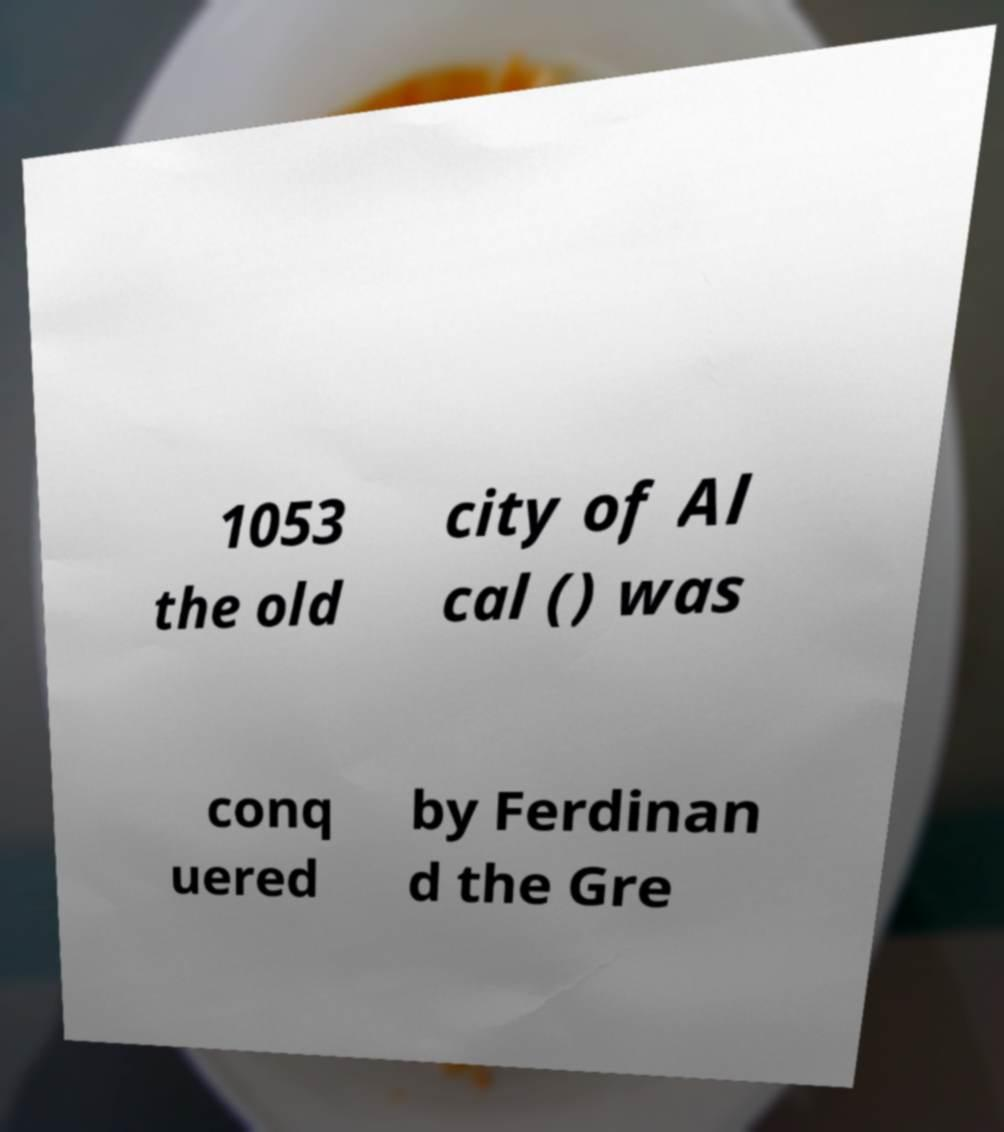Can you accurately transcribe the text from the provided image for me? 1053 the old city of Al cal () was conq uered by Ferdinan d the Gre 